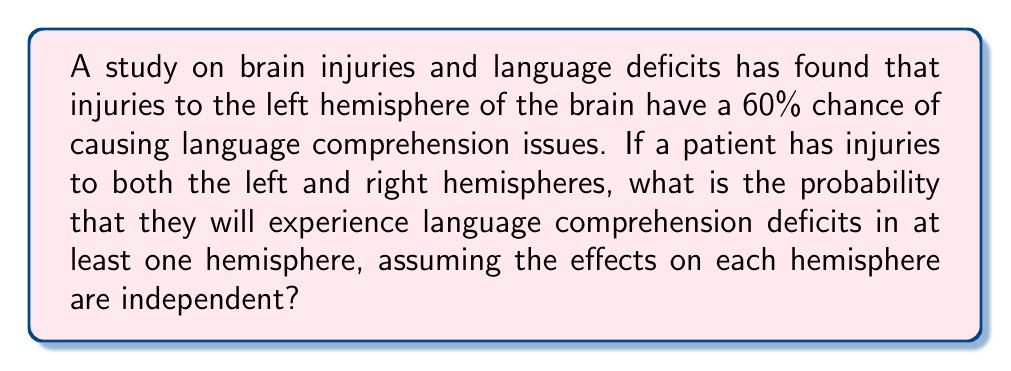Teach me how to tackle this problem. Let's approach this step-by-step:

1) Let $L$ be the event of language deficits due to left hemisphere injury, and $R$ be the event of language deficits due to right hemisphere injury.

2) We're given that $P(L) = 0.60$ for left hemisphere injuries.

3) The question doesn't specify the probability for right hemisphere injuries, so let's assume it's lower, say $P(R) = 0.30$.

4) We need to find the probability of language deficits in at least one hemisphere. This is equivalent to the probability of not having no deficits in either hemisphere.

5) Mathematically, this can be expressed as:

   $P(\text{at least one}) = 1 - P(\text{none})$

6) The probability of no deficits in either hemisphere is the product of the probabilities of no deficits in each hemisphere (since they're independent):

   $P(\text{none}) = (1 - P(L)) \times (1 - P(R))$

7) Substituting the values:

   $P(\text{none}) = (1 - 0.60) \times (1 - 0.30) = 0.40 \times 0.70 = 0.28$

8) Therefore, the probability of deficits in at least one hemisphere is:

   $P(\text{at least one}) = 1 - 0.28 = 0.72$

9) Convert to a percentage: $0.72 \times 100\% = 72\%$
Answer: 72% 